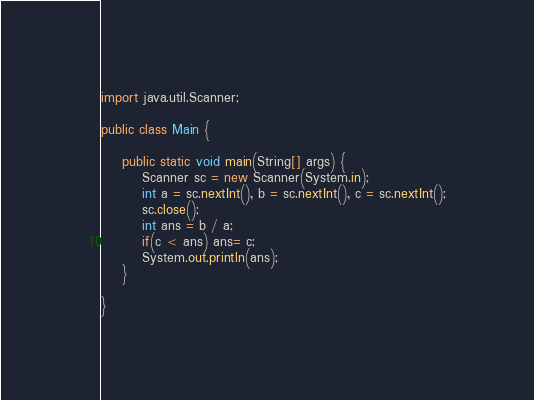Convert code to text. <code><loc_0><loc_0><loc_500><loc_500><_Java_>import java.util.Scanner;

public class Main {

	public static void main(String[] args) {
		Scanner sc = new Scanner(System.in);
		int a = sc.nextInt(), b = sc.nextInt(), c = sc.nextInt();
		sc.close();
		int ans = b / a;
		if(c < ans) ans= c;
		System.out.println(ans);
	}

}
</code> 